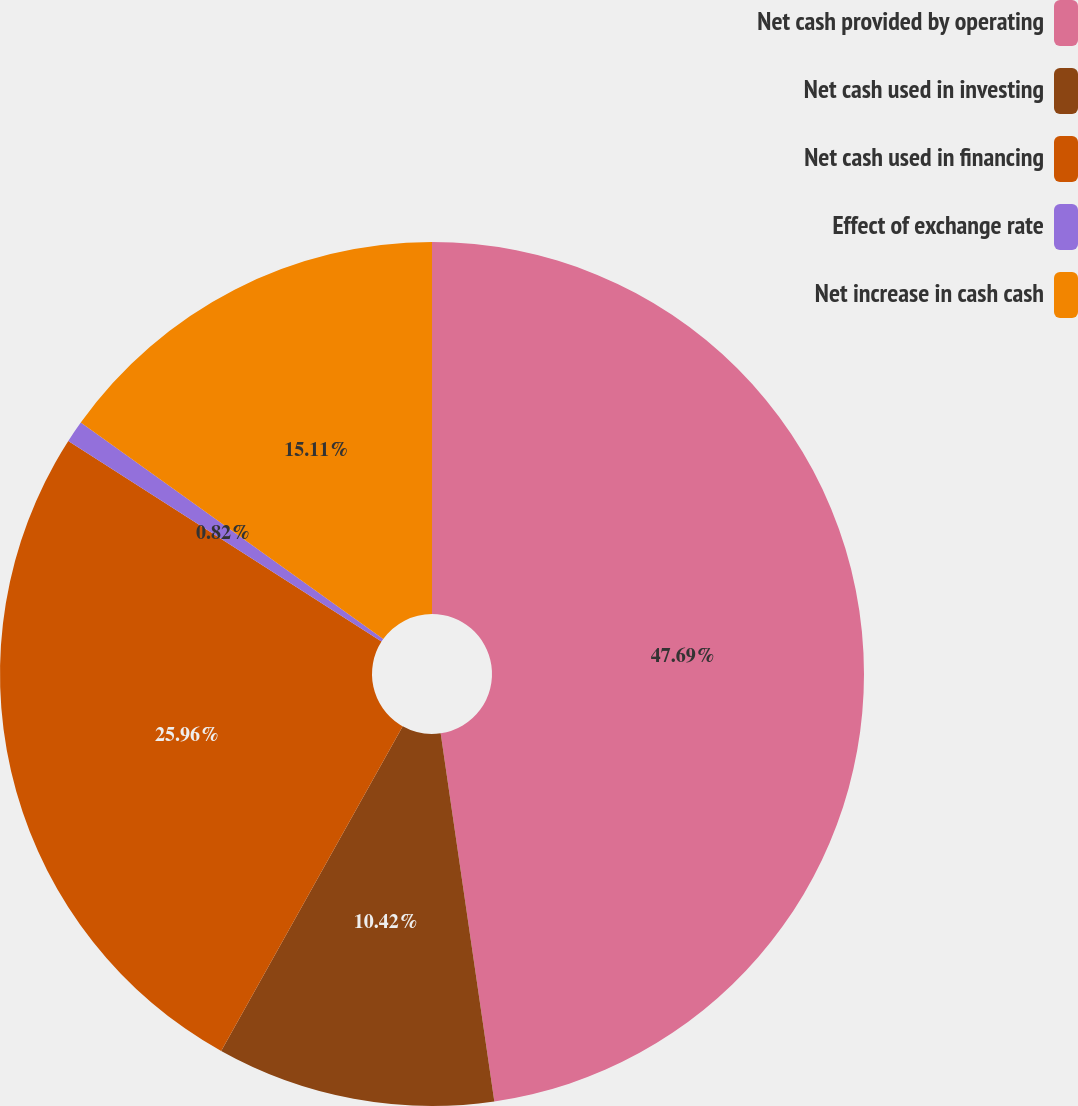Convert chart to OTSL. <chart><loc_0><loc_0><loc_500><loc_500><pie_chart><fcel>Net cash provided by operating<fcel>Net cash used in investing<fcel>Net cash used in financing<fcel>Effect of exchange rate<fcel>Net increase in cash cash<nl><fcel>47.7%<fcel>10.42%<fcel>25.96%<fcel>0.82%<fcel>15.11%<nl></chart> 